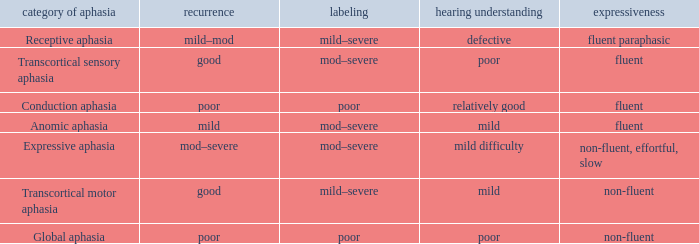Name the naming for fluent and poor comprehension Mod–severe. Could you parse the entire table? {'header': ['category of aphasia', 'recurrence', 'labeling', 'hearing understanding', 'expressiveness'], 'rows': [['Receptive aphasia', 'mild–mod', 'mild–severe', 'defective', 'fluent paraphasic'], ['Transcortical sensory aphasia', 'good', 'mod–severe', 'poor', 'fluent'], ['Conduction aphasia', 'poor', 'poor', 'relatively good', 'fluent'], ['Anomic aphasia', 'mild', 'mod–severe', 'mild', 'fluent'], ['Expressive aphasia', 'mod–severe', 'mod–severe', 'mild difficulty', 'non-fluent, effortful, slow'], ['Transcortical motor aphasia', 'good', 'mild–severe', 'mild', 'non-fluent'], ['Global aphasia', 'poor', 'poor', 'poor', 'non-fluent']]} 